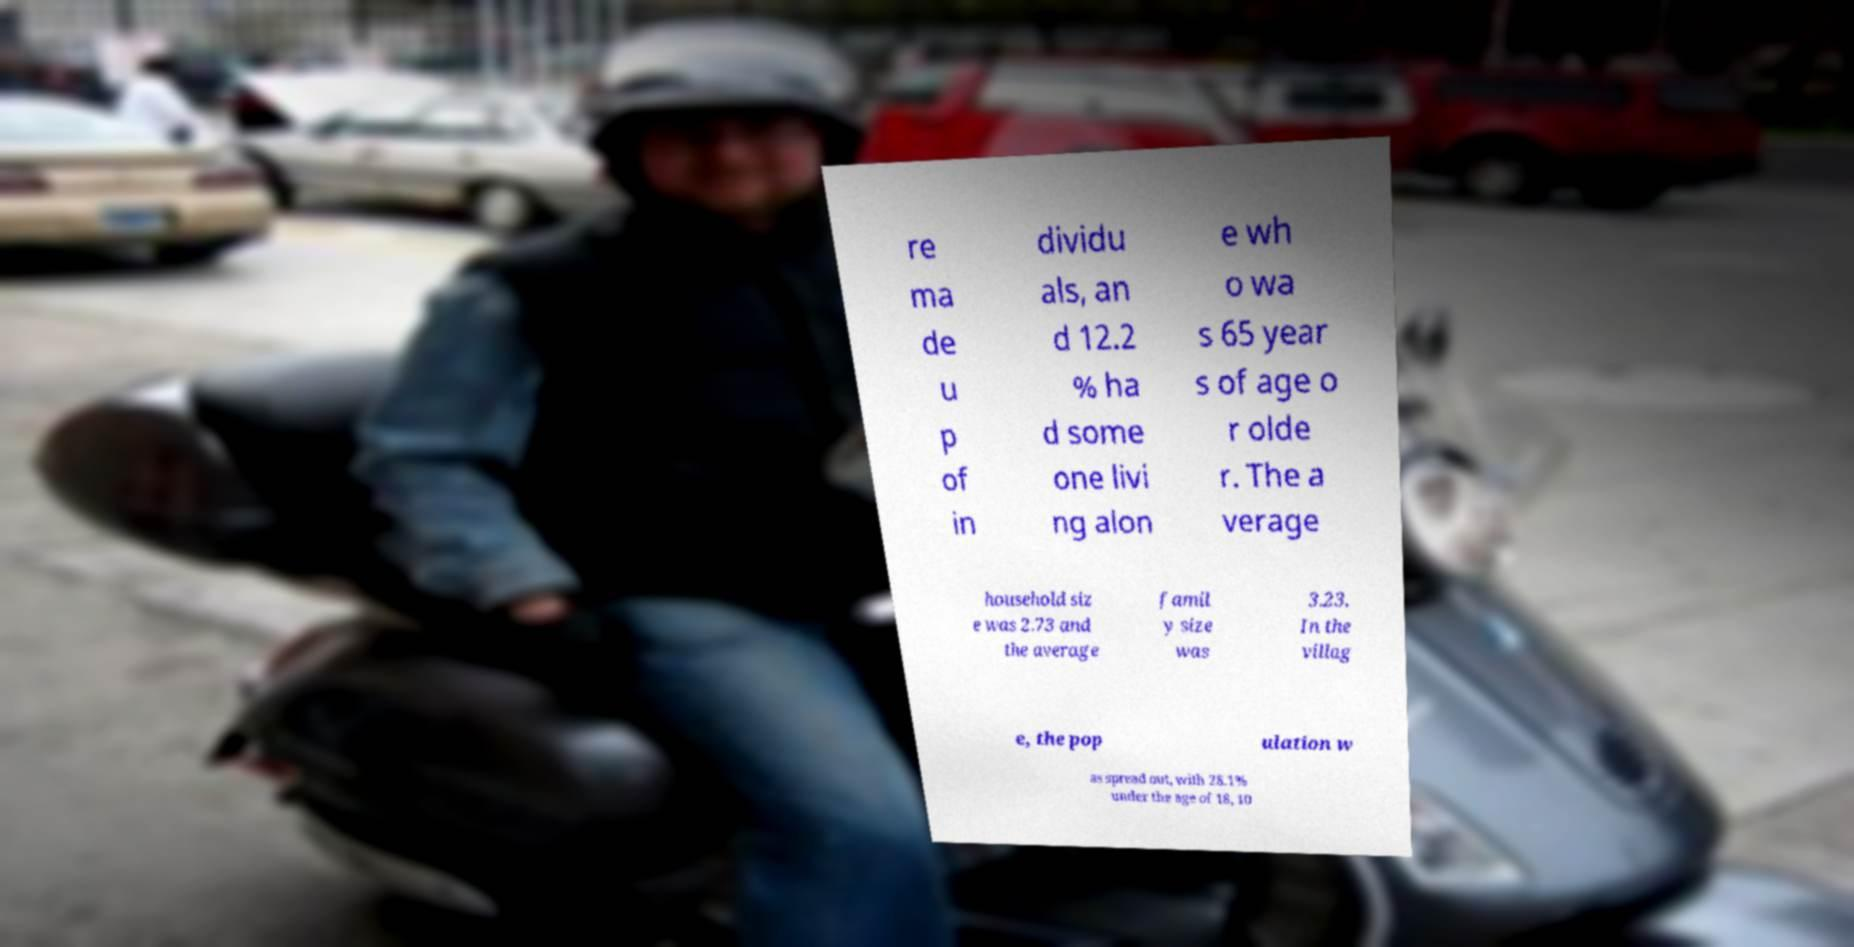Please identify and transcribe the text found in this image. re ma de u p of in dividu als, an d 12.2 % ha d some one livi ng alon e wh o wa s 65 year s of age o r olde r. The a verage household siz e was 2.73 and the average famil y size was 3.23. In the villag e, the pop ulation w as spread out, with 28.1% under the age of 18, 10 